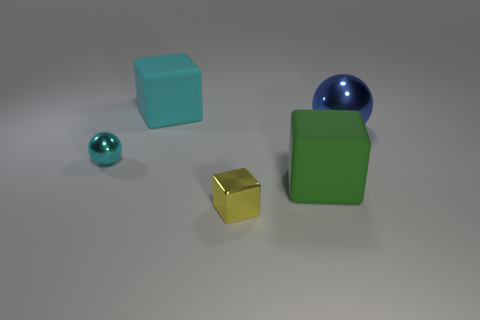There is a big thing that is the same color as the small metal sphere; what shape is it?
Your answer should be very brief. Cube. Is the small metallic ball the same color as the small block?
Provide a short and direct response. No. How many things are small green things or big cyan rubber objects that are behind the tiny block?
Your response must be concise. 1. Are there any green matte spheres that have the same size as the green object?
Your response must be concise. No. Is the material of the large sphere the same as the cyan block?
Offer a terse response. No. How many objects are either large cyan metal spheres or cubes?
Offer a terse response. 3. What is the size of the yellow thing?
Give a very brief answer. Small. Is the number of small metal cylinders less than the number of blue metal spheres?
Provide a short and direct response. Yes. What number of matte objects are the same color as the small block?
Your answer should be compact. 0. Do the matte object that is on the right side of the large cyan cube and the large sphere have the same color?
Ensure brevity in your answer.  No. 